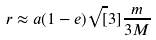<formula> <loc_0><loc_0><loc_500><loc_500>r \approx a ( 1 - e ) \sqrt { [ } 3 ] { \frac { m } { 3 M } }</formula> 